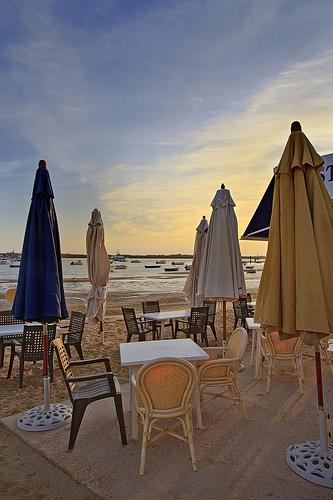Question: how many umbrellas are in the photo?
Choices:
A. Two.
B. Three.
C. Four.
D. Six.
Answer with the letter. Answer: D Question: why are the tables empty?
Choices:
A. Business is slow.
B. Closed.
C. The food is terrible.
D. It's the off-season.
Answer with the letter. Answer: B Question: what color are the tables?
Choices:
A. White.
B. Black.
C. Gray.
D. Brown.
Answer with the letter. Answer: A Question: where is the cafe located?
Choices:
A. Beach.
B. Busy city street.
C. In a rural setting.
D. At the mall.
Answer with the letter. Answer: A Question: what time of day is it?
Choices:
A. Morning.
B. Evening.
C. Afternoon.
D. Midnight.
Answer with the letter. Answer: B Question: where are the boats?
Choices:
A. Water.
B. On trailers.
C. In storage.
D. In the showroom.
Answer with the letter. Answer: A Question: what season is this?
Choices:
A. Winter.
B. Spring.
C. Fall.
D. Summer.
Answer with the letter. Answer: D 